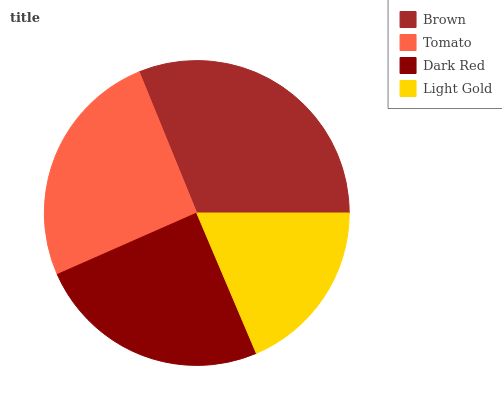Is Light Gold the minimum?
Answer yes or no. Yes. Is Brown the maximum?
Answer yes or no. Yes. Is Tomato the minimum?
Answer yes or no. No. Is Tomato the maximum?
Answer yes or no. No. Is Brown greater than Tomato?
Answer yes or no. Yes. Is Tomato less than Brown?
Answer yes or no. Yes. Is Tomato greater than Brown?
Answer yes or no. No. Is Brown less than Tomato?
Answer yes or no. No. Is Tomato the high median?
Answer yes or no. Yes. Is Dark Red the low median?
Answer yes or no. Yes. Is Light Gold the high median?
Answer yes or no. No. Is Light Gold the low median?
Answer yes or no. No. 